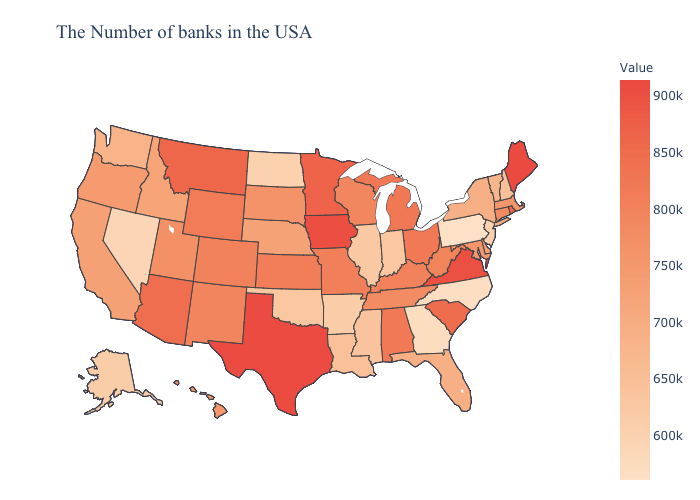Among the states that border Missouri , which have the highest value?
Keep it brief. Iowa. Does the map have missing data?
Quick response, please. No. 